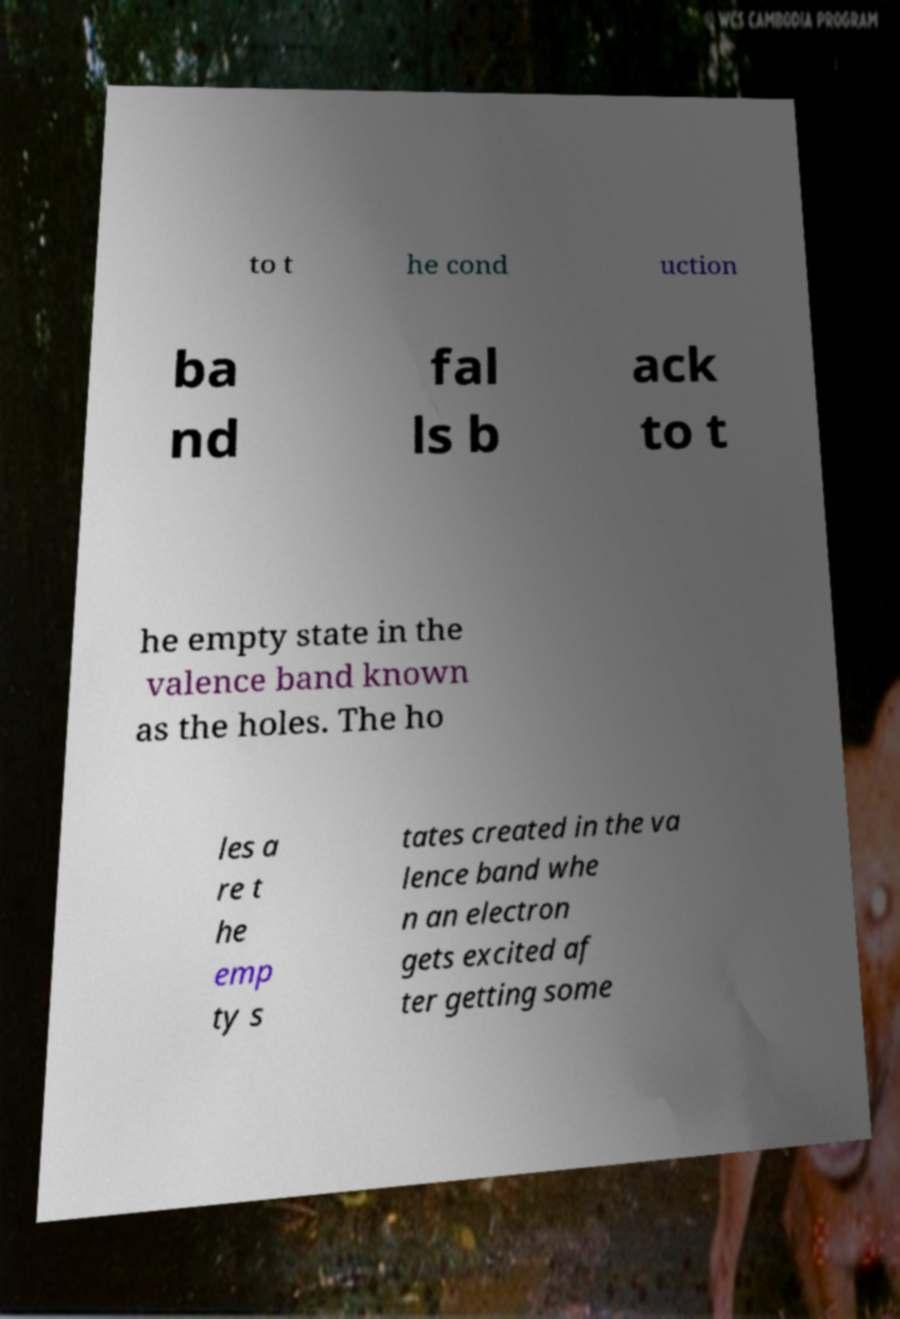Can you read and provide the text displayed in the image?This photo seems to have some interesting text. Can you extract and type it out for me? to t he cond uction ba nd fal ls b ack to t he empty state in the valence band known as the holes. The ho les a re t he emp ty s tates created in the va lence band whe n an electron gets excited af ter getting some 